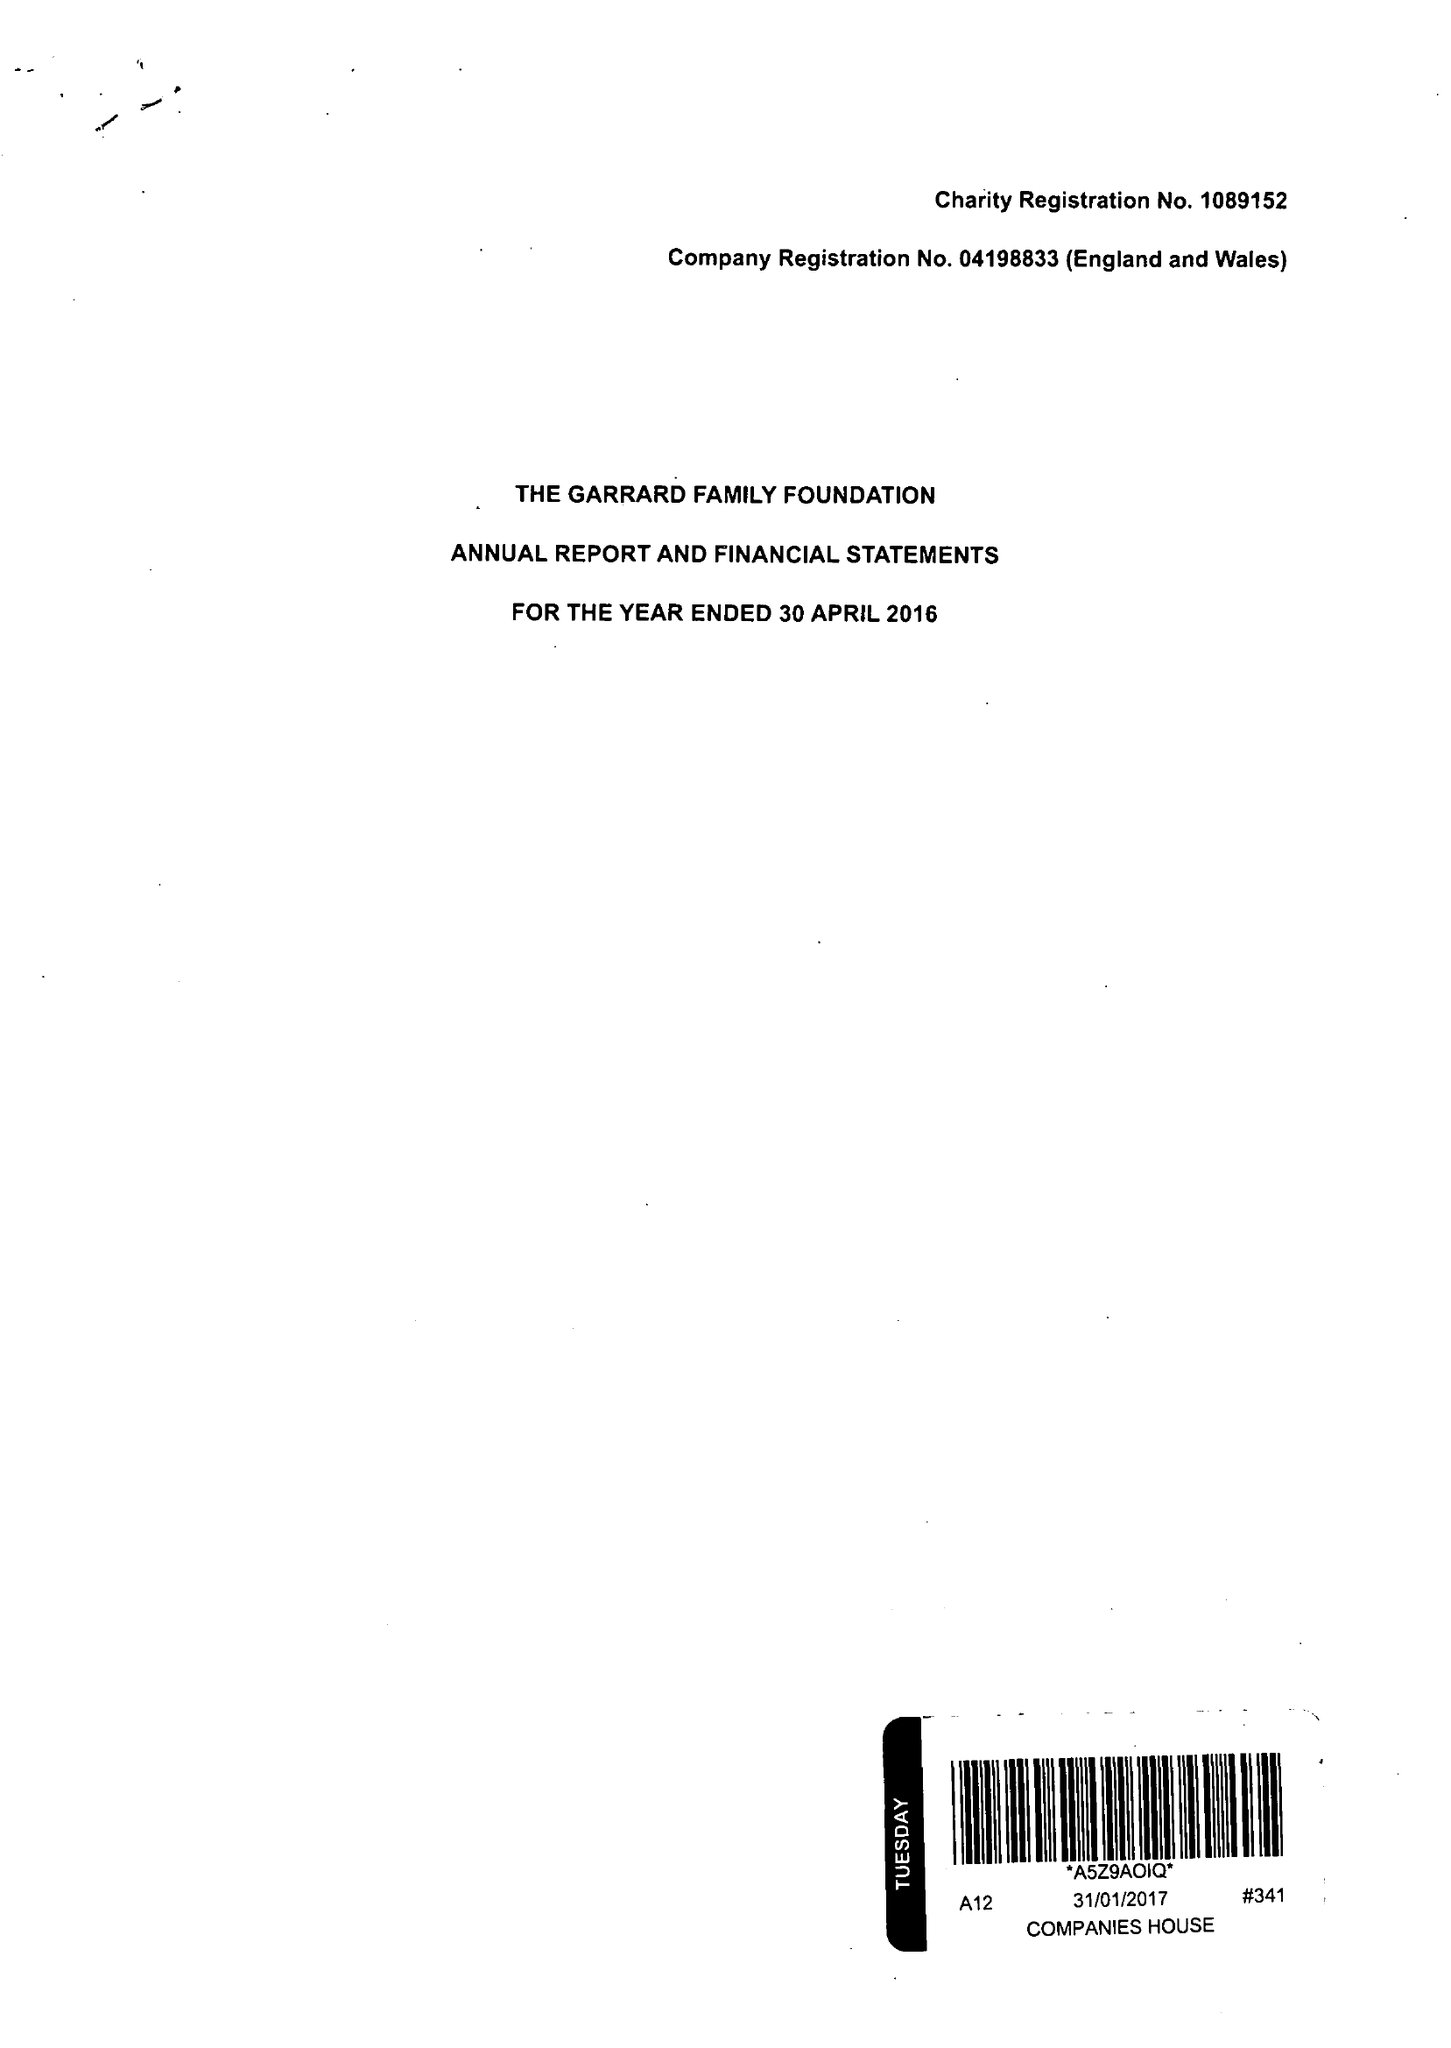What is the value for the spending_annually_in_british_pounds?
Answer the question using a single word or phrase. 183602.00 